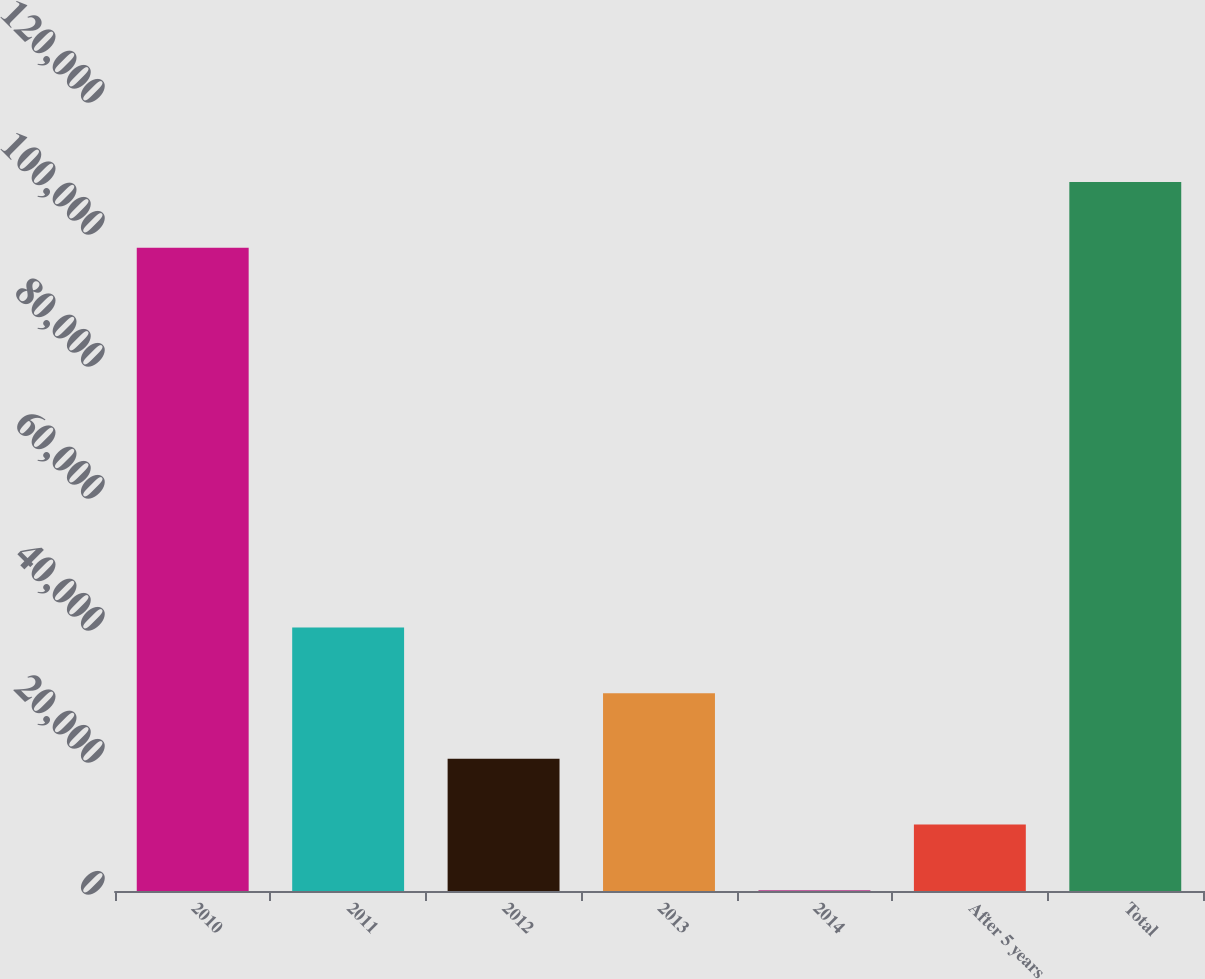Convert chart. <chart><loc_0><loc_0><loc_500><loc_500><bar_chart><fcel>2010<fcel>2011<fcel>2012<fcel>2013<fcel>2014<fcel>After 5 years<fcel>Total<nl><fcel>97465<fcel>39929<fcel>20028<fcel>29978.5<fcel>127<fcel>10077.5<fcel>107416<nl></chart> 